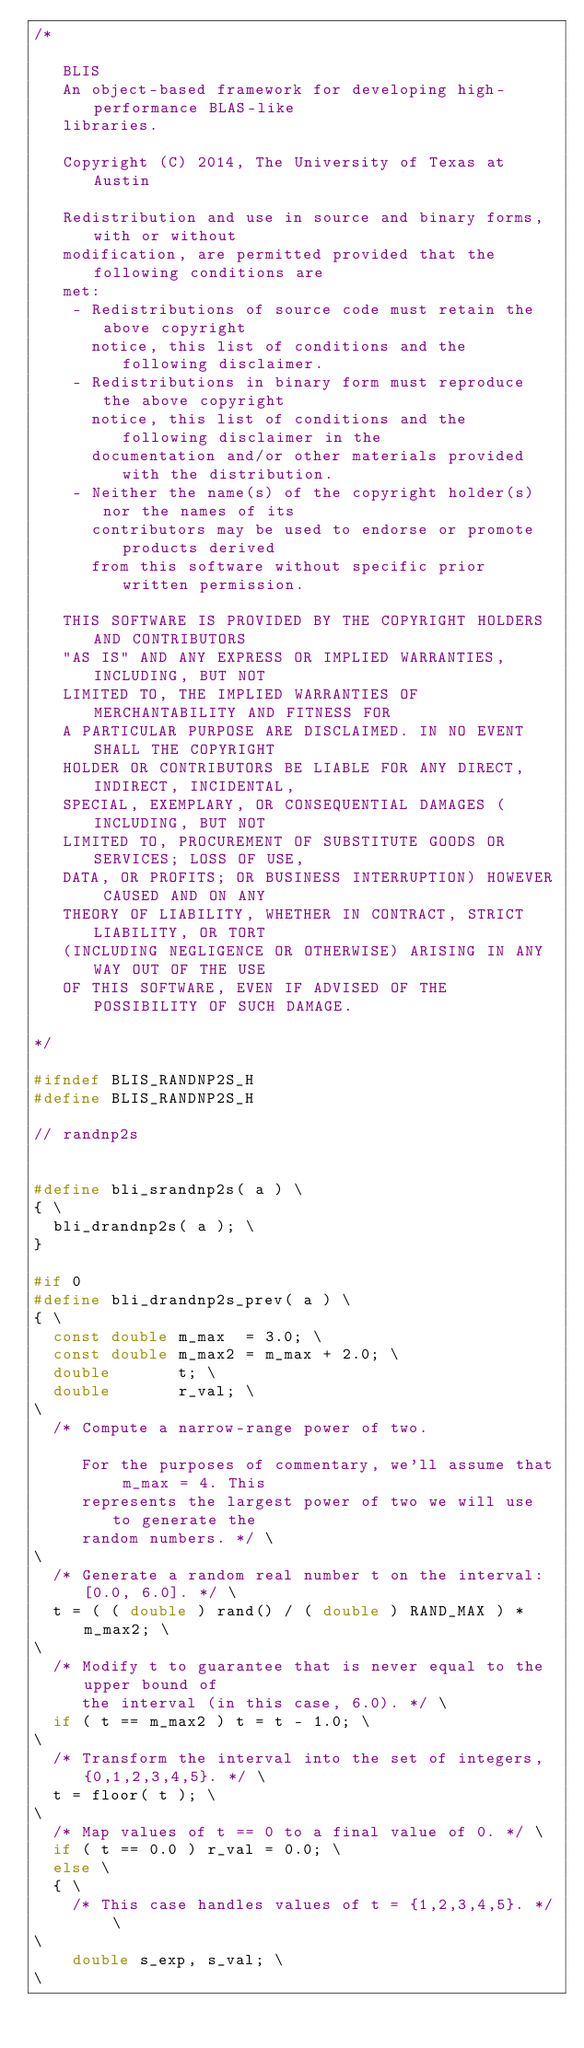<code> <loc_0><loc_0><loc_500><loc_500><_C_>/*

   BLIS
   An object-based framework for developing high-performance BLAS-like
   libraries.

   Copyright (C) 2014, The University of Texas at Austin

   Redistribution and use in source and binary forms, with or without
   modification, are permitted provided that the following conditions are
   met:
    - Redistributions of source code must retain the above copyright
      notice, this list of conditions and the following disclaimer.
    - Redistributions in binary form must reproduce the above copyright
      notice, this list of conditions and the following disclaimer in the
      documentation and/or other materials provided with the distribution.
    - Neither the name(s) of the copyright holder(s) nor the names of its
      contributors may be used to endorse or promote products derived
      from this software without specific prior written permission.

   THIS SOFTWARE IS PROVIDED BY THE COPYRIGHT HOLDERS AND CONTRIBUTORS
   "AS IS" AND ANY EXPRESS OR IMPLIED WARRANTIES, INCLUDING, BUT NOT
   LIMITED TO, THE IMPLIED WARRANTIES OF MERCHANTABILITY AND FITNESS FOR
   A PARTICULAR PURPOSE ARE DISCLAIMED. IN NO EVENT SHALL THE COPYRIGHT
   HOLDER OR CONTRIBUTORS BE LIABLE FOR ANY DIRECT, INDIRECT, INCIDENTAL,
   SPECIAL, EXEMPLARY, OR CONSEQUENTIAL DAMAGES (INCLUDING, BUT NOT
   LIMITED TO, PROCUREMENT OF SUBSTITUTE GOODS OR SERVICES; LOSS OF USE,
   DATA, OR PROFITS; OR BUSINESS INTERRUPTION) HOWEVER CAUSED AND ON ANY
   THEORY OF LIABILITY, WHETHER IN CONTRACT, STRICT LIABILITY, OR TORT
   (INCLUDING NEGLIGENCE OR OTHERWISE) ARISING IN ANY WAY OUT OF THE USE
   OF THIS SOFTWARE, EVEN IF ADVISED OF THE POSSIBILITY OF SUCH DAMAGE.

*/

#ifndef BLIS_RANDNP2S_H
#define BLIS_RANDNP2S_H

// randnp2s


#define bli_srandnp2s( a ) \
{ \
	bli_drandnp2s( a ); \
}

#if 0
#define bli_drandnp2s_prev( a ) \
{ \
	const double m_max  = 3.0; \
	const double m_max2 = m_max + 2.0; \
	double       t; \
	double       r_val; \
\
	/* Compute a narrow-range power of two.

	   For the purposes of commentary, we'll assume that m_max = 4. This
	   represents the largest power of two we will use to generate the
	   random numbers. */ \
\
	/* Generate a random real number t on the interval: [0.0, 6.0]. */ \
	t = ( ( double ) rand() / ( double ) RAND_MAX ) * m_max2; \
\
	/* Modify t to guarantee that is never equal to the upper bound of
	   the interval (in this case, 6.0). */ \
	if ( t == m_max2 ) t = t - 1.0; \
\
	/* Transform the interval into the set of integers, {0,1,2,3,4,5}. */ \
	t = floor( t ); \
\
	/* Map values of t == 0 to a final value of 0. */ \
	if ( t == 0.0 ) r_val = 0.0; \
	else \
	{ \
		/* This case handles values of t = {1,2,3,4,5}. */ \
\
		double s_exp, s_val; \
\</code> 